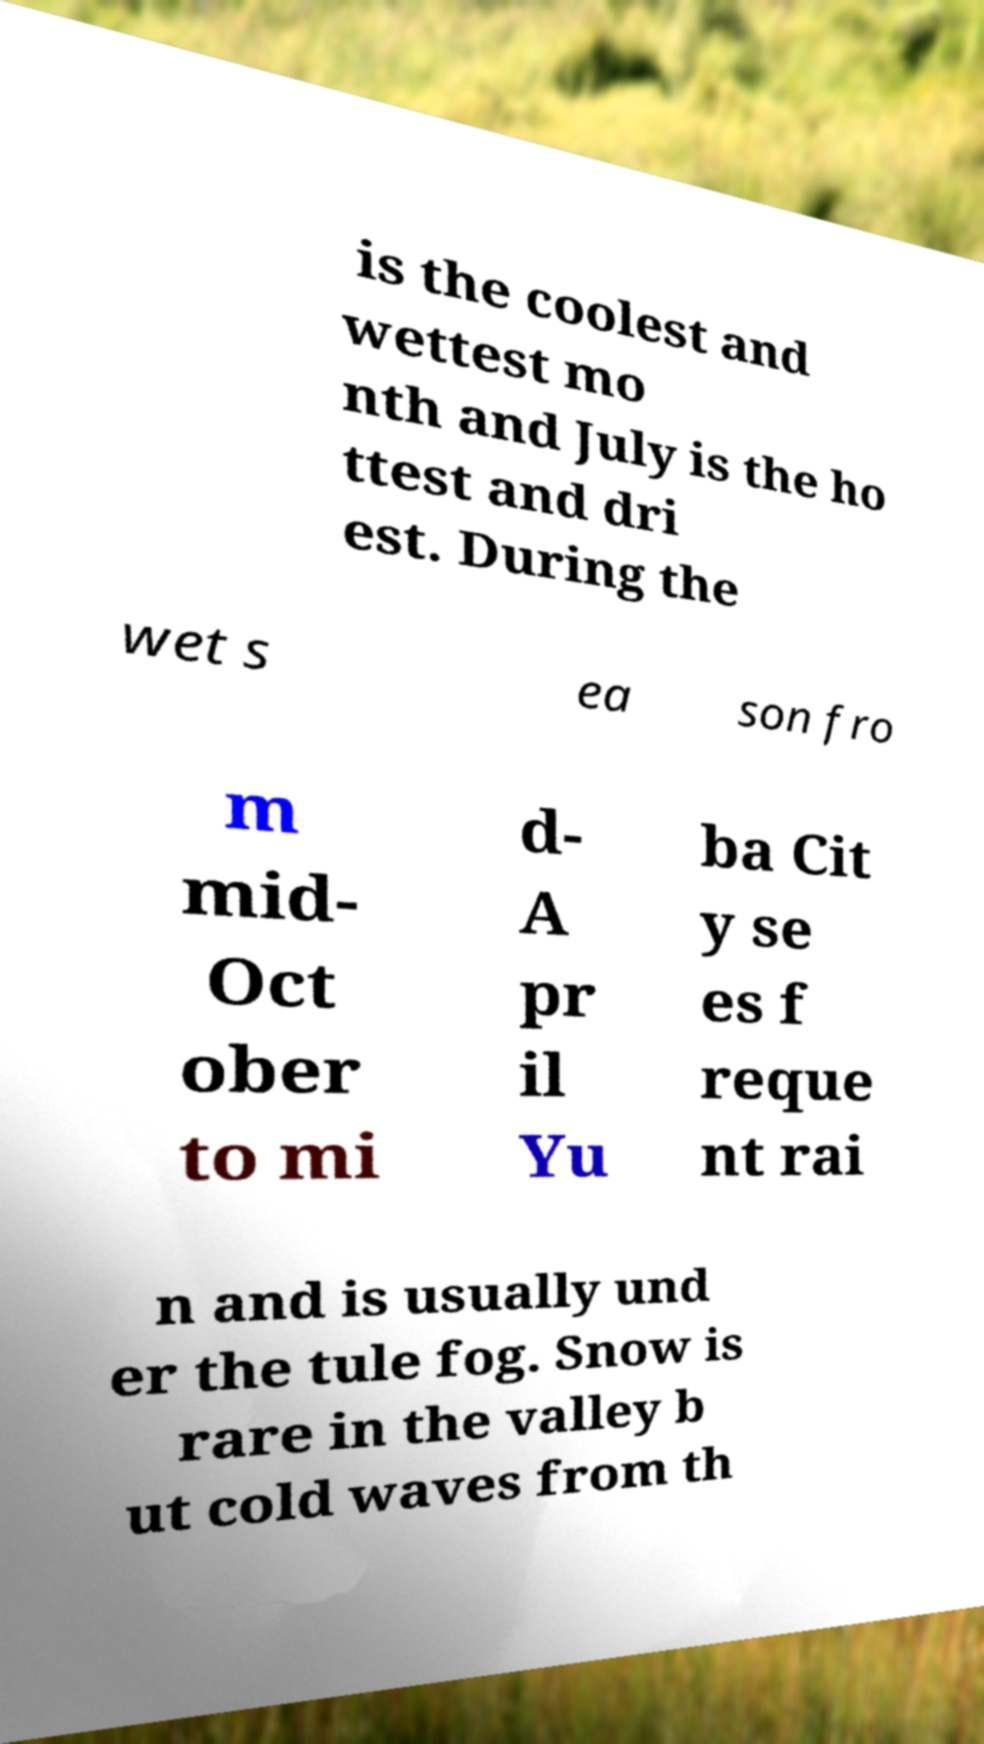Can you accurately transcribe the text from the provided image for me? is the coolest and wettest mo nth and July is the ho ttest and dri est. During the wet s ea son fro m mid- Oct ober to mi d- A pr il Yu ba Cit y se es f reque nt rai n and is usually und er the tule fog. Snow is rare in the valley b ut cold waves from th 